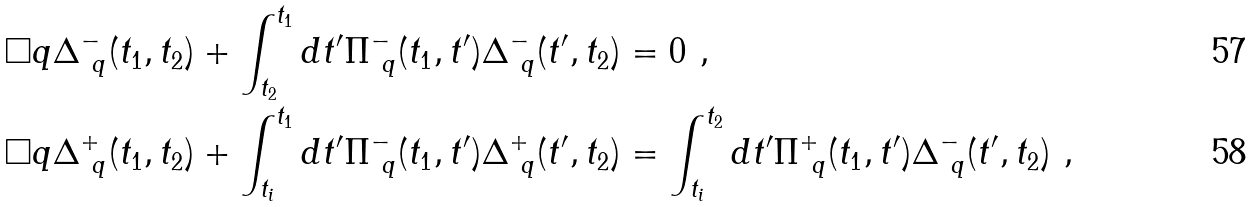Convert formula to latex. <formula><loc_0><loc_0><loc_500><loc_500>& \Box q \Delta ^ { - } _ { \ q } ( t _ { 1 } , t _ { 2 } ) + \int _ { t _ { 2 } } ^ { t _ { 1 } } d t ^ { \prime } \Pi ^ { - } _ { \ q } ( t _ { 1 } , t ^ { \prime } ) \Delta ^ { - } _ { \ q } ( t ^ { \prime } , t _ { 2 } ) = 0 \ , \\ & \Box q \Delta ^ { + } _ { \ q } ( t _ { 1 } , t _ { 2 } ) + \int _ { t _ { i } } ^ { t _ { 1 } } d t ^ { \prime } \Pi ^ { - } _ { \ q } ( t _ { 1 } , t ^ { \prime } ) \Delta ^ { + } _ { \ q } ( t ^ { \prime } , t _ { 2 } ) = \int _ { t _ { i } } ^ { t _ { 2 } } d t ^ { \prime } \Pi ^ { + } _ { \ q } ( t _ { 1 } , t ^ { \prime } ) \Delta ^ { - } _ { \ q } ( t ^ { \prime } , t _ { 2 } ) \ ,</formula> 